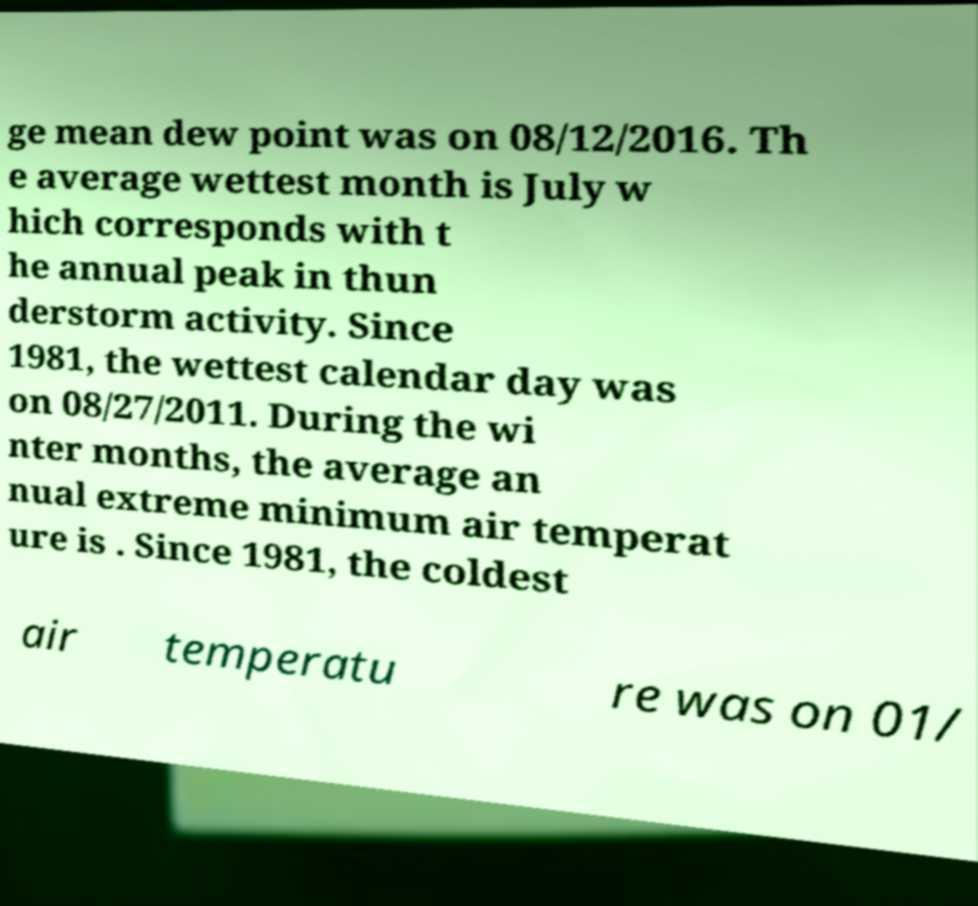Can you read and provide the text displayed in the image?This photo seems to have some interesting text. Can you extract and type it out for me? ge mean dew point was on 08/12/2016. Th e average wettest month is July w hich corresponds with t he annual peak in thun derstorm activity. Since 1981, the wettest calendar day was on 08/27/2011. During the wi nter months, the average an nual extreme minimum air temperat ure is . Since 1981, the coldest air temperatu re was on 01/ 